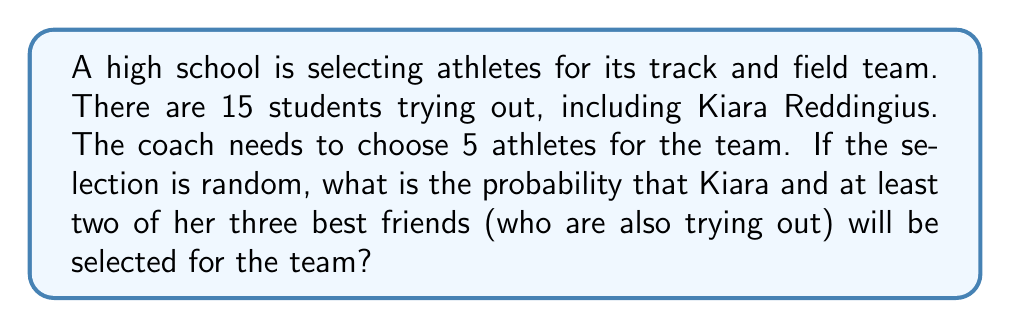Give your solution to this math problem. Let's approach this step-by-step:

1) First, we need to calculate the total number of ways to select 5 athletes from 15 students. This is a combination problem:

   $${15 \choose 5} = \frac{15!}{5!(15-5)!} = \frac{15!}{5!10!} = 3003$$

2) Now, we need to calculate the favorable outcomes. We can break this into two cases:
   a) Kiara and all 3 of her friends are selected, plus 1 other student
   b) Kiara and 2 of her friends are selected, plus 2 other students

3) For case a:
   - Kiara and her 3 friends are already selected
   - We need to choose 1 more from the remaining 11 students
   $${11 \choose 1} = 11$$

4) For case b:
   - Kiara is already selected
   - We need to choose 2 out of her 3 friends: ${3 \choose 2} = 3$
   - We need to choose 2 from the remaining 11 students: ${11 \choose 2} = 55$
   - Total for this case: $3 * 55 = 165$

5) Total favorable outcomes: $11 + 165 = 176$

6) Probability = Favorable outcomes / Total outcomes
   $$P = \frac{176}{3003} \approx 0.0586$$
Answer: $\frac{176}{3003} \approx 0.0586$ 